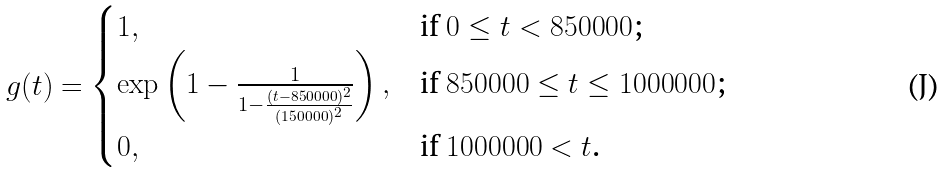Convert formula to latex. <formula><loc_0><loc_0><loc_500><loc_500>g ( t ) = \begin{cases} 1 , & \text {if $0\leq t < 850000$;} \\ \exp \left ( 1 - \frac { 1 } { 1 - \frac { ( t - 8 5 0 0 0 0 ) ^ { 2 } } { ( 1 5 0 0 0 0 ) ^ { 2 } } } \right ) , & \text {if $850000 \leq t \leq 1000000$;} \\ 0 , & \text {if $1000000 < t $.} \end{cases}</formula> 